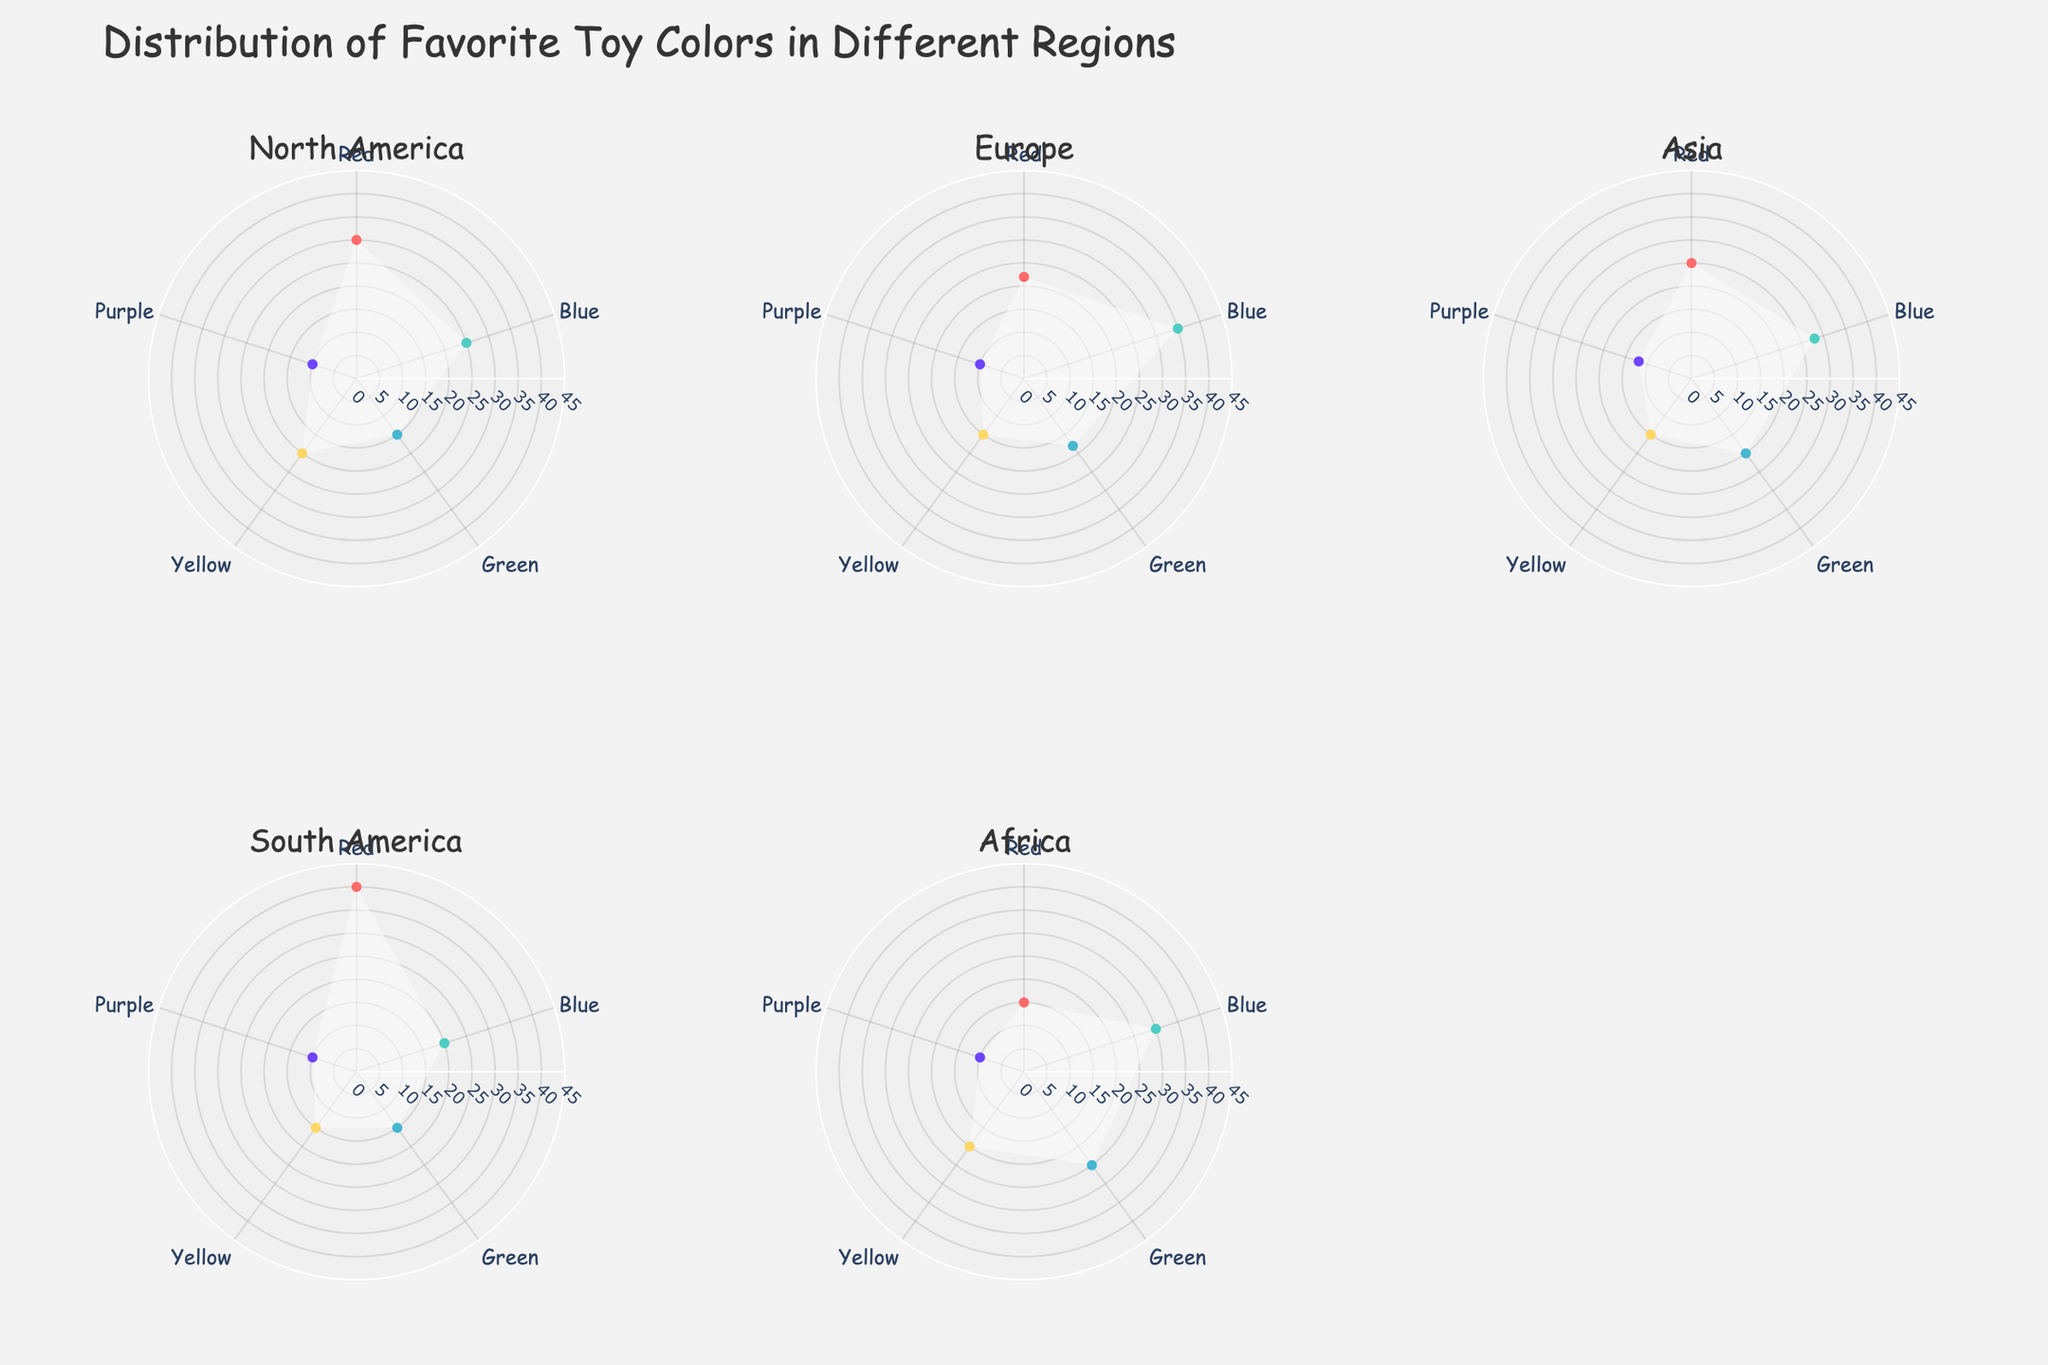What is the title of the figure? The title is typically located at the top center of a chart. In this figure, the title is a summarized representation of the dataset.
Answer: Distribution of Favorite Toy Colors in Different Regions Which region has the highest percentage of toy color 'Red'? By examining the individual subplots for each region, we look for the highest value for the color 'Red'. North America has 30%, Europe has 22%, Asia has 25%, South America has 40%, and Africa has 15%.
Answer: South America How many regions are shown in the figure? There's one subplot for each region. Counting these subplots, we get North America, Europe, Asia, South America, and Africa.
Answer: 5 What is the least favorite toy color in North America? We look for the color with the smallest percentage in the North America subplot. The percentages for colors are 30% for Red, 25% for Blue, 15% for Green, 20% for Yellow, and 10% for Purple.
Answer: Purple Which region prefers the color 'Blue' the most? Check all regions for the highest percentage of 'Blue'. North America has 25%, Europe has 35%, Asia has 28%, South America has 20%, and Africa has 30%.
Answer: Europe What is the combined percentage of 'Green' and 'Yellow' toy colors in Africa? Summing up the percentages for 'Green' (25%) and 'Yellow' (20%) in Africa.
Answer: 45% Which region shows a more balanced distribution of toy colors without any percentages exceeding 40%? Compare each region's maximum percentage for any color. North America's highest is 30%, Europe's is 35%, Asia's is 28%, South America's is 40%, and Africa's is 30%. Only North America, Europe, Asia, and Africa fit the criteria.
Answer: North America, Europe, Asia, Africa How does the popularity of 'Purple' toy color in Europe compare to its popularity in Asia? Comparing the percentages for 'Purple' color in both regions. Europe has 10% and Asia has 12%.
Answer: Less than What is the average percentage of the 'Yellow' toy color across all regions? Adding percentages for 'Yellow' in all regions (20% from North America, 15% from Europe, 15% from Asia, 15% from South America, 20% from Africa) and dividing by the number of regions (5).
Answer: 17% In which region are 'Red' and 'Blue' toy colors equally popular? Checking each region for equal percentages of 'Red' and 'Blue'. North America (Red: 30%, Blue: 25%), Europe (Red: 22%, Blue: 35%), Asia (Red: 25%, Blue: 28%), South America (Red: 40%, Blue: 20%), Africa (Red: 15%, Blue: 30%). None of the regions have equal percentages for 'Red' and 'Blue'.
Answer: None 